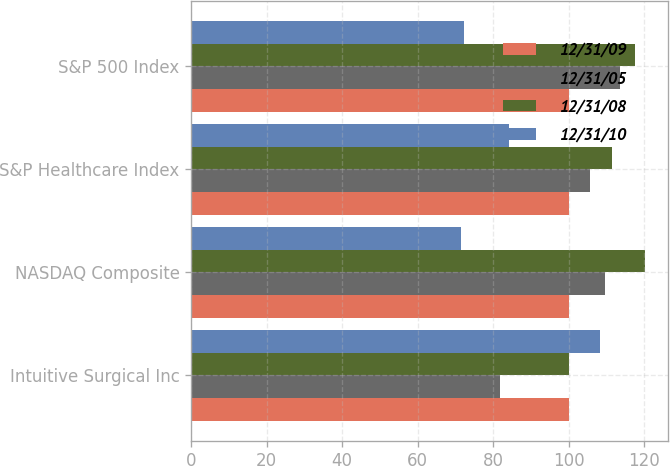Convert chart. <chart><loc_0><loc_0><loc_500><loc_500><stacked_bar_chart><ecel><fcel>Intuitive Surgical Inc<fcel>NASDAQ Composite<fcel>S&P Healthcare Index<fcel>S&P 500 Index<nl><fcel>12/31/09<fcel>100<fcel>100<fcel>100<fcel>100<nl><fcel>12/31/05<fcel>81.78<fcel>109.52<fcel>105.78<fcel>113.62<nl><fcel>12/31/08<fcel>100<fcel>120.27<fcel>111.49<fcel>117.63<nl><fcel>12/31/10<fcel>108.29<fcel>71.51<fcel>84.2<fcel>72.36<nl></chart> 